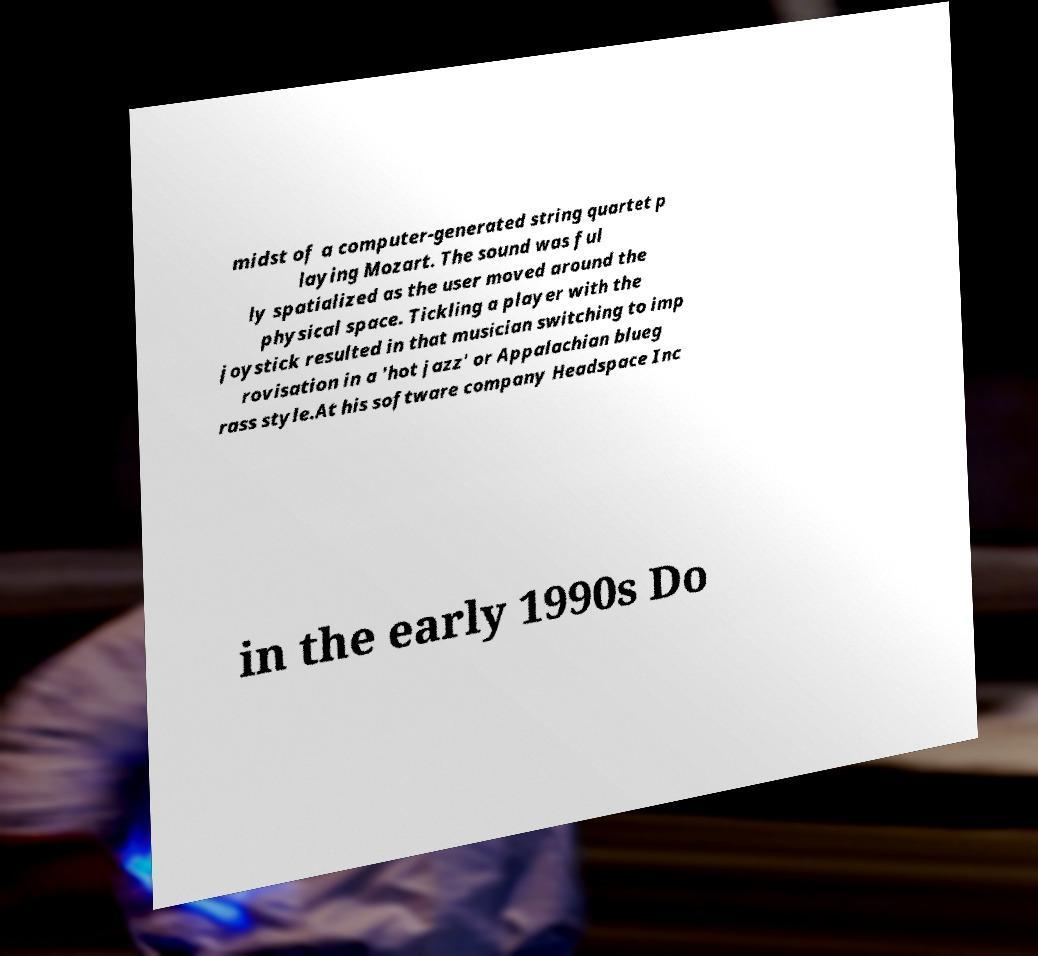Can you accurately transcribe the text from the provided image for me? midst of a computer-generated string quartet p laying Mozart. The sound was ful ly spatialized as the user moved around the physical space. Tickling a player with the joystick resulted in that musician switching to imp rovisation in a 'hot jazz' or Appalachian blueg rass style.At his software company Headspace Inc in the early 1990s Do 